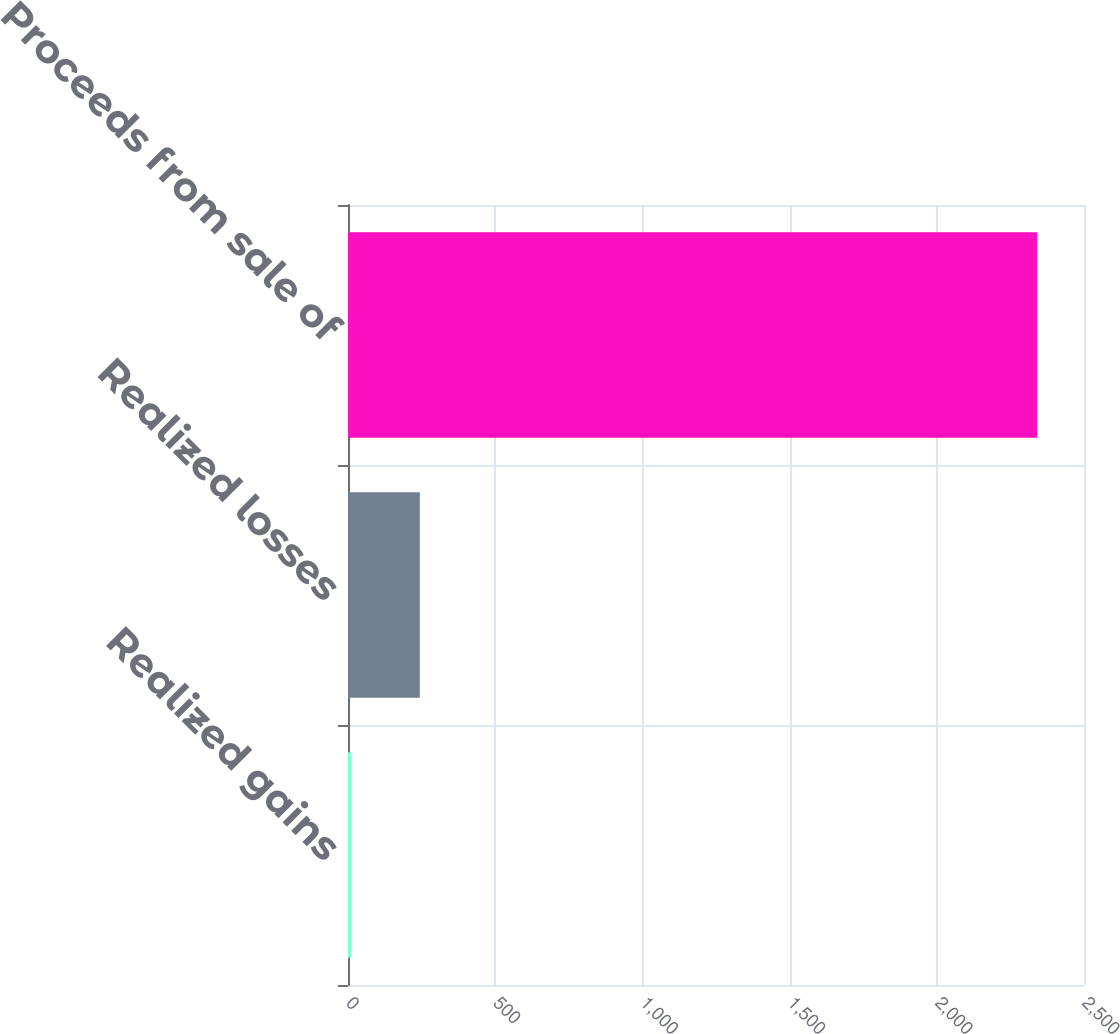Convert chart. <chart><loc_0><loc_0><loc_500><loc_500><bar_chart><fcel>Realized gains<fcel>Realized losses<fcel>Proceeds from sale of<nl><fcel>11<fcel>244<fcel>2341<nl></chart> 